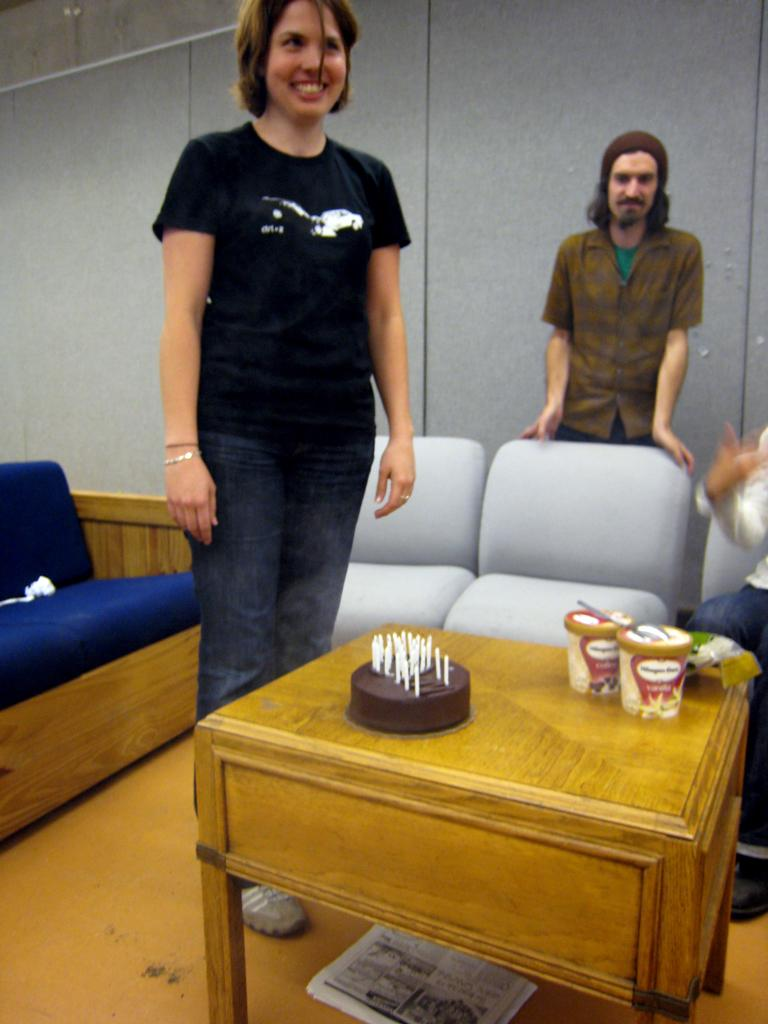Who are the people in the image? There is a woman and a man standing in the image. What is on the table in the image? There is a cake on the table, along with containers. What can be seen in the background of the image? There are couches and a wall visible in the background. What country is the maid from in the image? There is no maid present in the image, and therefore no country of origin can be determined. 